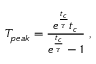Convert formula to latex. <formula><loc_0><loc_0><loc_500><loc_500>T _ { p e a k } = \frac { e ^ { \frac { t _ { c } } { \tau } } t _ { c } } { e ^ { \frac { t _ { c } } { \tau } } - 1 } ,</formula> 